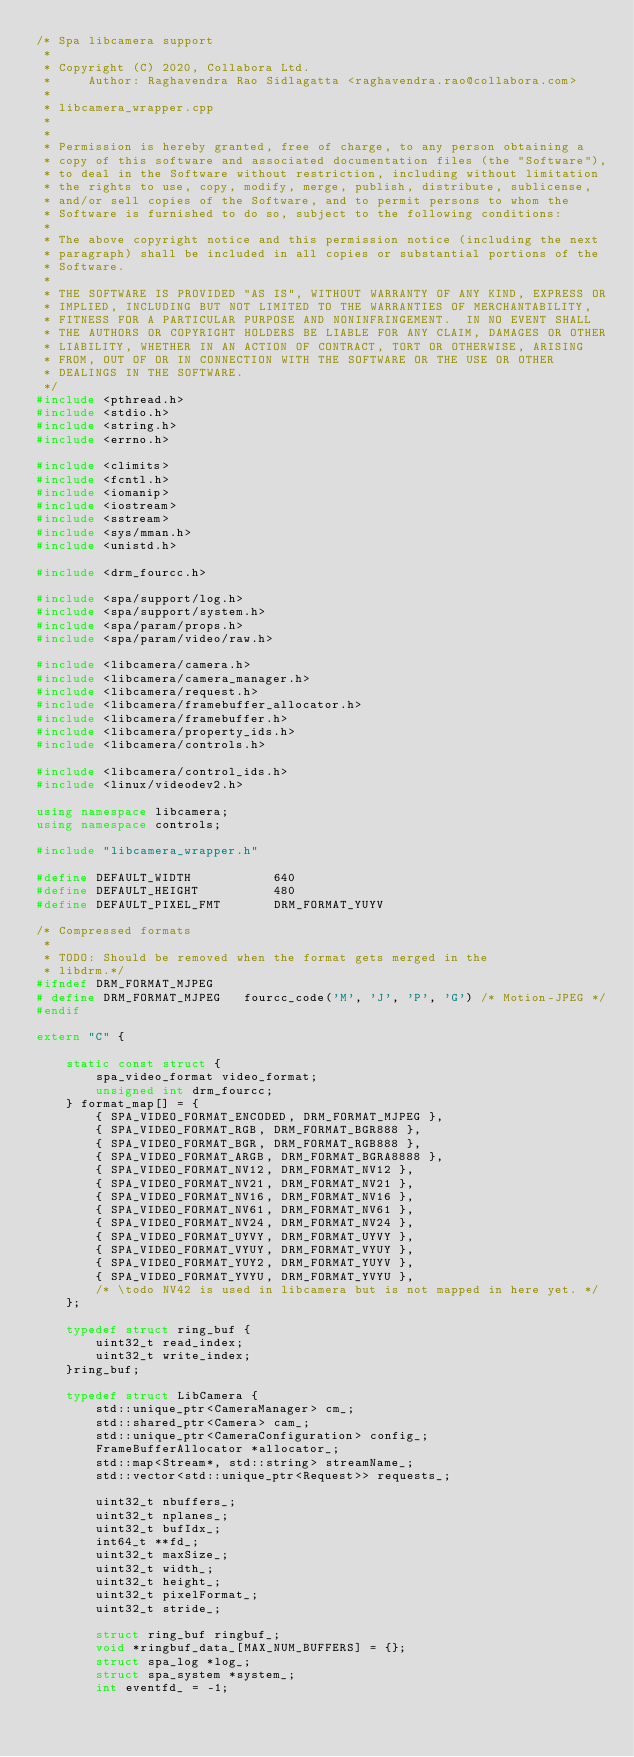<code> <loc_0><loc_0><loc_500><loc_500><_C++_>/* Spa libcamera support
 *
 * Copyright (C) 2020, Collabora Ltd.
 *     Author: Raghavendra Rao Sidlagatta <raghavendra.rao@collabora.com>
 *
 * libcamera_wrapper.cpp
 *
 *
 * Permission is hereby granted, free of charge, to any person obtaining a
 * copy of this software and associated documentation files (the "Software"),
 * to deal in the Software without restriction, including without limitation
 * the rights to use, copy, modify, merge, publish, distribute, sublicense,
 * and/or sell copies of the Software, and to permit persons to whom the
 * Software is furnished to do so, subject to the following conditions:
 *
 * The above copyright notice and this permission notice (including the next
 * paragraph) shall be included in all copies or substantial portions of the
 * Software.
 *
 * THE SOFTWARE IS PROVIDED "AS IS", WITHOUT WARRANTY OF ANY KIND, EXPRESS OR
 * IMPLIED, INCLUDING BUT NOT LIMITED TO THE WARRANTIES OF MERCHANTABILITY,
 * FITNESS FOR A PARTICULAR PURPOSE AND NONINFRINGEMENT.  IN NO EVENT SHALL
 * THE AUTHORS OR COPYRIGHT HOLDERS BE LIABLE FOR ANY CLAIM, DAMAGES OR OTHER
 * LIABILITY, WHETHER IN AN ACTION OF CONTRACT, TORT OR OTHERWISE, ARISING
 * FROM, OUT OF OR IN CONNECTION WITH THE SOFTWARE OR THE USE OR OTHER
 * DEALINGS IN THE SOFTWARE.
 */
#include <pthread.h>
#include <stdio.h>
#include <string.h>
#include <errno.h>

#include <climits>
#include <fcntl.h>
#include <iomanip>
#include <iostream>
#include <sstream>
#include <sys/mman.h>
#include <unistd.h>

#include <drm_fourcc.h>

#include <spa/support/log.h>
#include <spa/support/system.h>
#include <spa/param/props.h>
#include <spa/param/video/raw.h>

#include <libcamera/camera.h>
#include <libcamera/camera_manager.h>
#include <libcamera/request.h>
#include <libcamera/framebuffer_allocator.h>
#include <libcamera/framebuffer.h>
#include <libcamera/property_ids.h>
#include <libcamera/controls.h>

#include <libcamera/control_ids.h>
#include <linux/videodev2.h>

using namespace libcamera;
using namespace controls;

#include "libcamera_wrapper.h"

#define DEFAULT_WIDTH			640
#define DEFAULT_HEIGHT			480
#define DEFAULT_PIXEL_FMT		DRM_FORMAT_YUYV

/* Compressed formats
 *
 * TODO: Should be removed when the format gets merged in the
 * libdrm.*/
#ifndef DRM_FORMAT_MJPEG
# define DRM_FORMAT_MJPEG	fourcc_code('M', 'J', 'P', 'G') /* Motion-JPEG */
#endif

extern "C" {

	static const struct {
		spa_video_format video_format;
		unsigned int drm_fourcc;
	} format_map[] = {
		{ SPA_VIDEO_FORMAT_ENCODED, DRM_FORMAT_MJPEG },
		{ SPA_VIDEO_FORMAT_RGB, DRM_FORMAT_BGR888 },
		{ SPA_VIDEO_FORMAT_BGR, DRM_FORMAT_RGB888 },
		{ SPA_VIDEO_FORMAT_ARGB, DRM_FORMAT_BGRA8888 },
		{ SPA_VIDEO_FORMAT_NV12, DRM_FORMAT_NV12 },
		{ SPA_VIDEO_FORMAT_NV21, DRM_FORMAT_NV21 },
		{ SPA_VIDEO_FORMAT_NV16, DRM_FORMAT_NV16 },
		{ SPA_VIDEO_FORMAT_NV61, DRM_FORMAT_NV61 },
		{ SPA_VIDEO_FORMAT_NV24, DRM_FORMAT_NV24 },
		{ SPA_VIDEO_FORMAT_UYVY, DRM_FORMAT_UYVY },
		{ SPA_VIDEO_FORMAT_VYUY, DRM_FORMAT_VYUY },
		{ SPA_VIDEO_FORMAT_YUY2, DRM_FORMAT_YUYV },
		{ SPA_VIDEO_FORMAT_YVYU, DRM_FORMAT_YVYU },
		/* \todo NV42 is used in libcamera but is not mapped in here yet. */
	};

	typedef struct ring_buf {
		uint32_t read_index;
		uint32_t write_index;
	}ring_buf;

	typedef struct LibCamera {
		std::unique_ptr<CameraManager> cm_;
		std::shared_ptr<Camera> cam_;
		std::unique_ptr<CameraConfiguration> config_;
		FrameBufferAllocator *allocator_;
		std::map<Stream*, std::string> streamName_;
		std::vector<std::unique_ptr<Request>> requests_;

		uint32_t nbuffers_;
		uint32_t nplanes_;
		uint32_t bufIdx_;
		int64_t **fd_;
		uint32_t maxSize_;
		uint32_t width_;
		uint32_t height_;
		uint32_t pixelFormat_;
		uint32_t stride_;

		struct ring_buf ringbuf_;
		void *ringbuf_data_[MAX_NUM_BUFFERS] = {};
		struct spa_log *log_;
		struct spa_system *system_;
		int eventfd_ = -1;</code> 